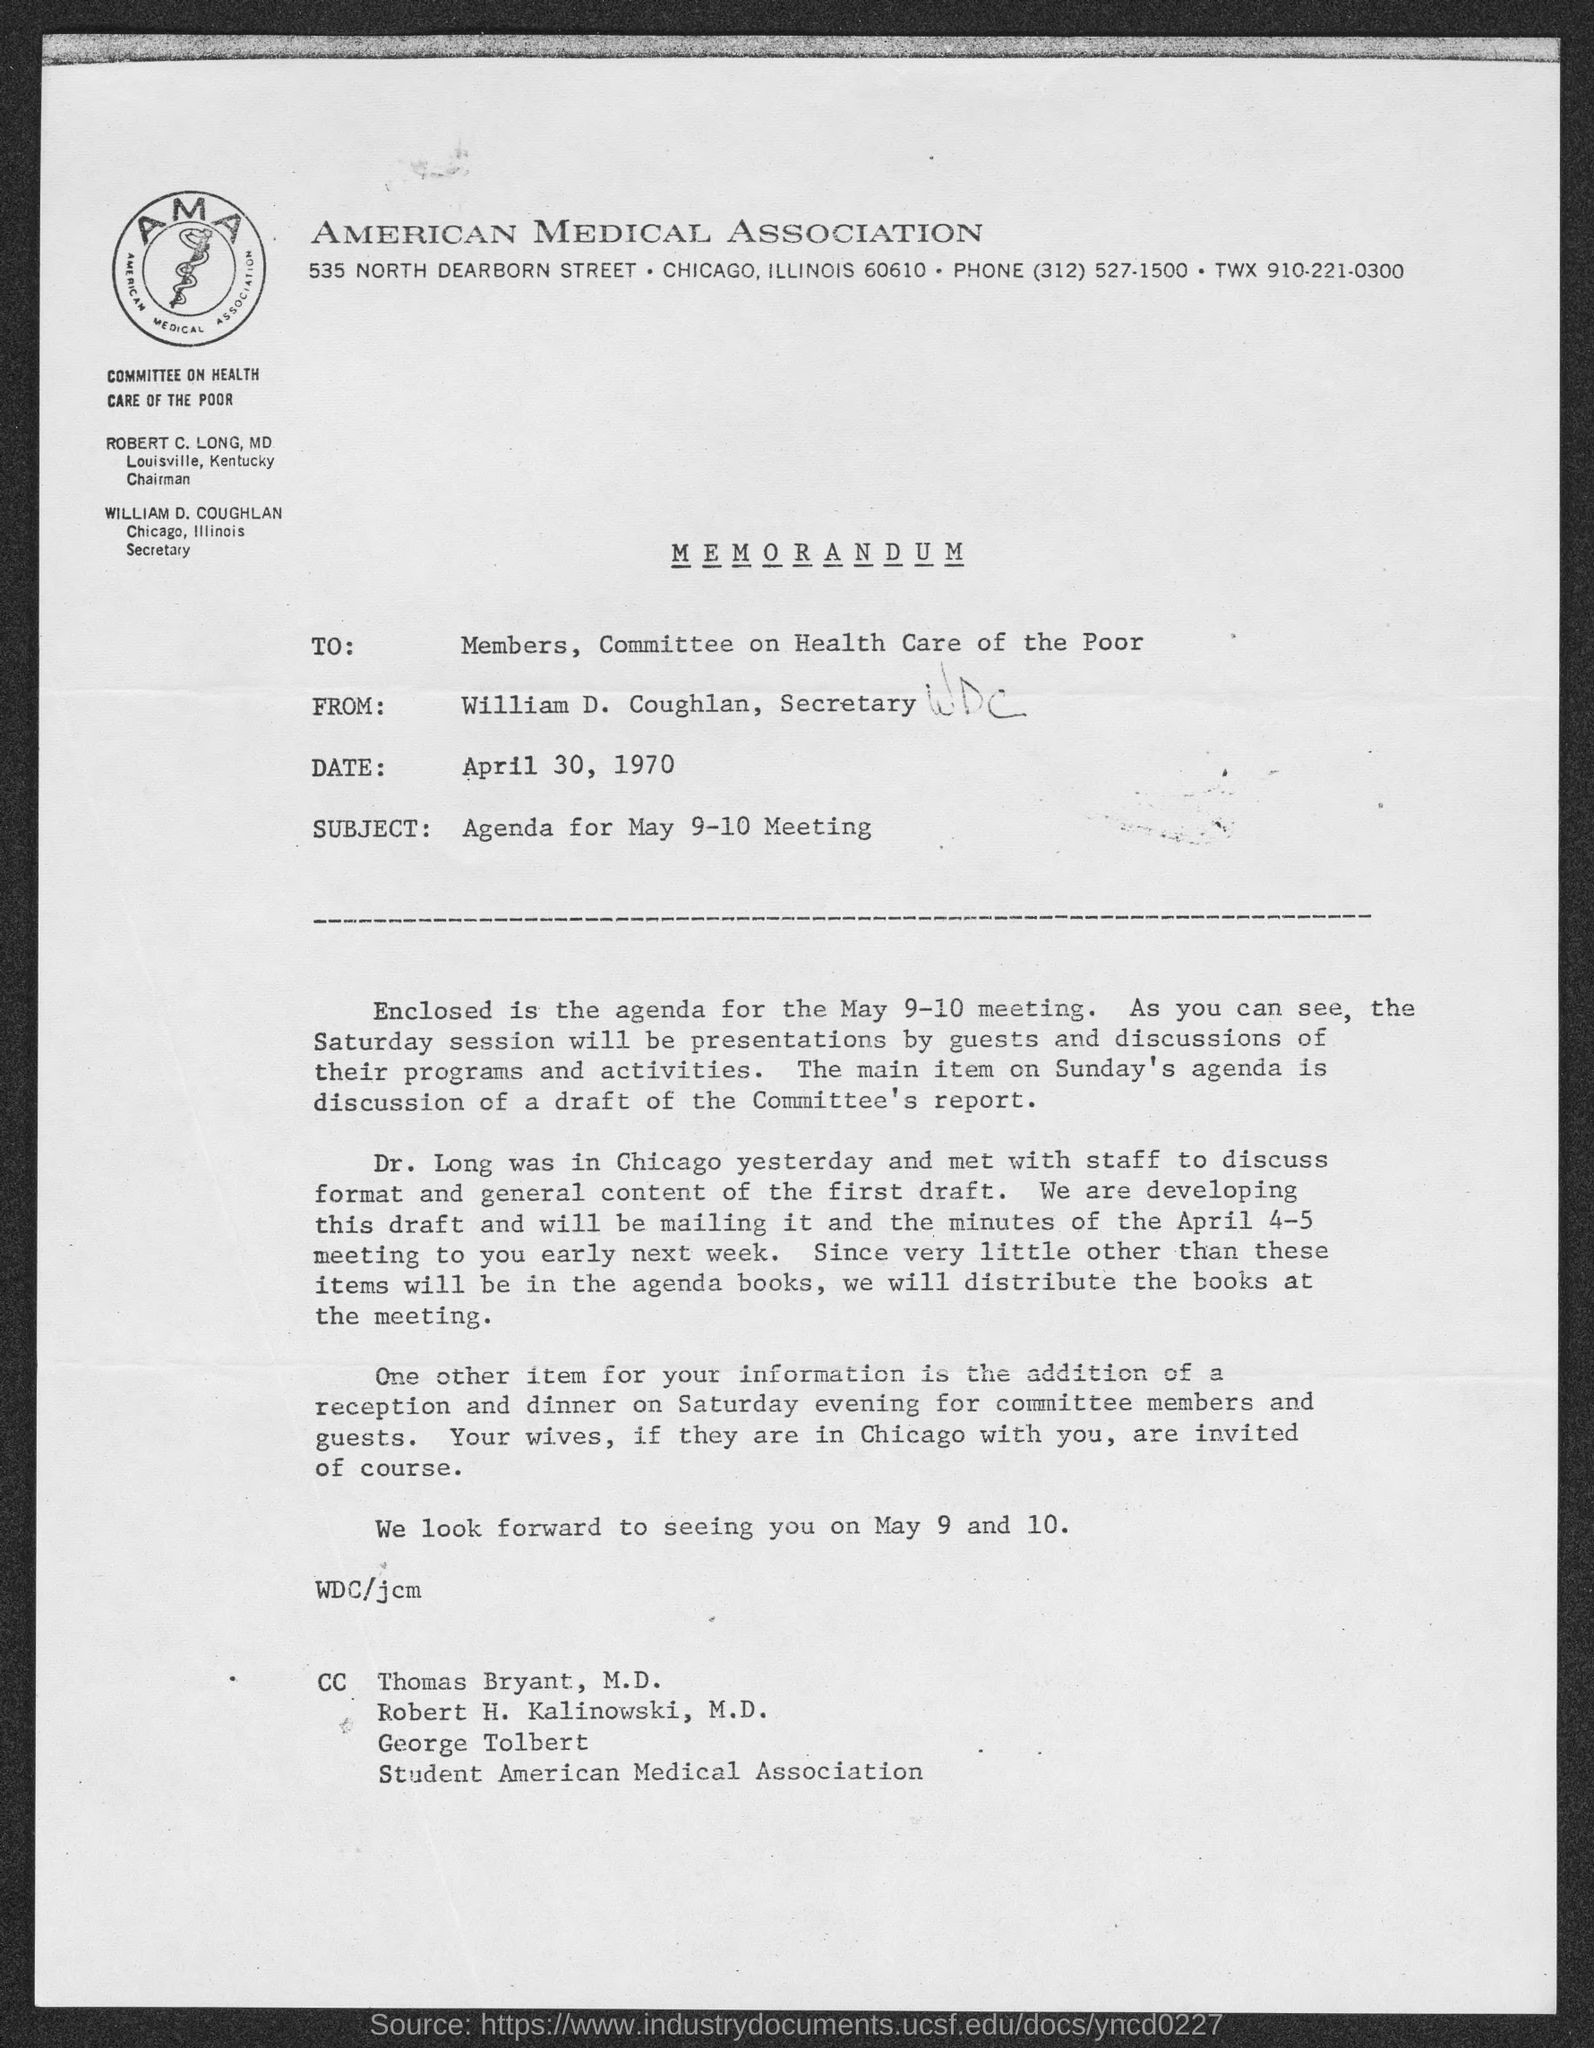What kind of communication is this ?
Your answer should be compact. Memorandum. Who is the sender of this memorandum?
Keep it short and to the point. William D. Coughlan, Secretary. What is the date mentioned in this memorandum?
Make the answer very short. April 30, 1970. Who is the receiver of this memorandum ?
Give a very brief answer. Members, committee on health care of the poor. What is the subject mentioned in the memorandum?
Provide a succinct answer. Agenda for may 9-10 meeting. 